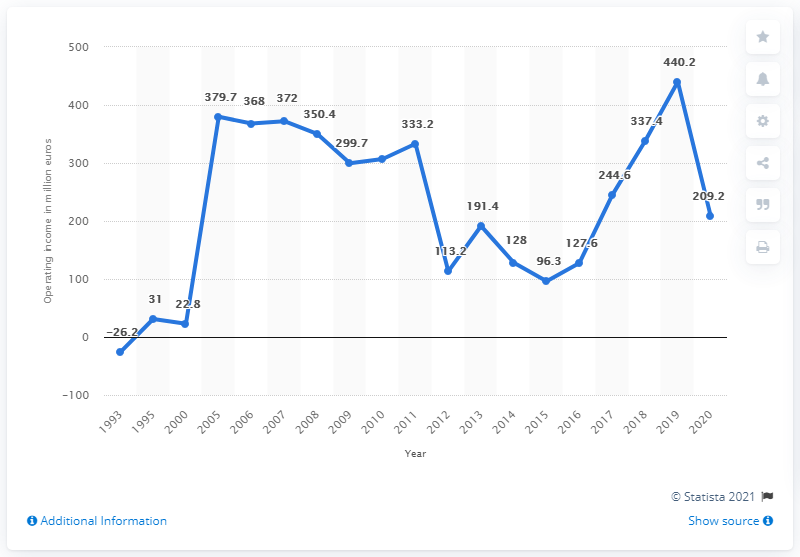How does the company's performance in 2007 compare to previous years? The data in the graph for 2007 shows one of the highest operating incomes within the considered timeframe, indicating strong performance. It surpasses most of the previous years, suggesting growth or successful business strategies.  Could you estimate the operating income growth rate from 1993 to 2007? To estimate the growth rate, we'd look at the operating income in 1993, which was at a loss, and compare it to 2007's high. Since operating income fluctuated significantly from year to year, calculating a precise growth rate would require a compound annual growth rate (CAGR) calculation method, which is not feasible with the information provided in the image alone. 